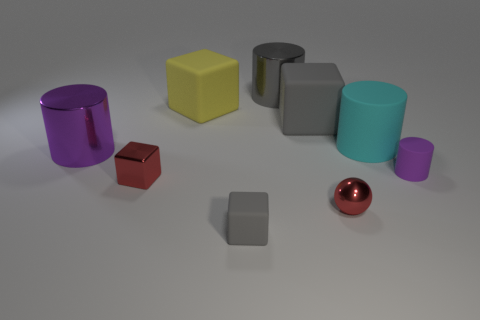What number of other things are the same color as the tiny rubber block?
Make the answer very short. 2. Are there fewer yellow rubber cubes that are behind the big yellow matte block than matte objects behind the cyan thing?
Keep it short and to the point. Yes. How many things are large cylinders that are to the left of the tiny ball or green matte cylinders?
Keep it short and to the point. 2. There is a red shiny cube; is its size the same as the shiny sphere that is to the right of the big gray rubber block?
Provide a short and direct response. Yes. There is a yellow object that is the same shape as the large gray matte thing; what is its size?
Your answer should be very brief. Large. What number of large matte objects are left of the gray rubber object to the left of the gray cube behind the small red metal ball?
Your answer should be compact. 1. How many blocks are either small cyan things or large things?
Offer a terse response. 2. There is a big cube on the left side of the gray object that is in front of the purple cylinder that is on the left side of the cyan rubber cylinder; what color is it?
Provide a succinct answer. Yellow. How many other things are there of the same size as the purple rubber object?
Your answer should be very brief. 3. The other matte object that is the same shape as the small purple rubber object is what color?
Offer a very short reply. Cyan. 